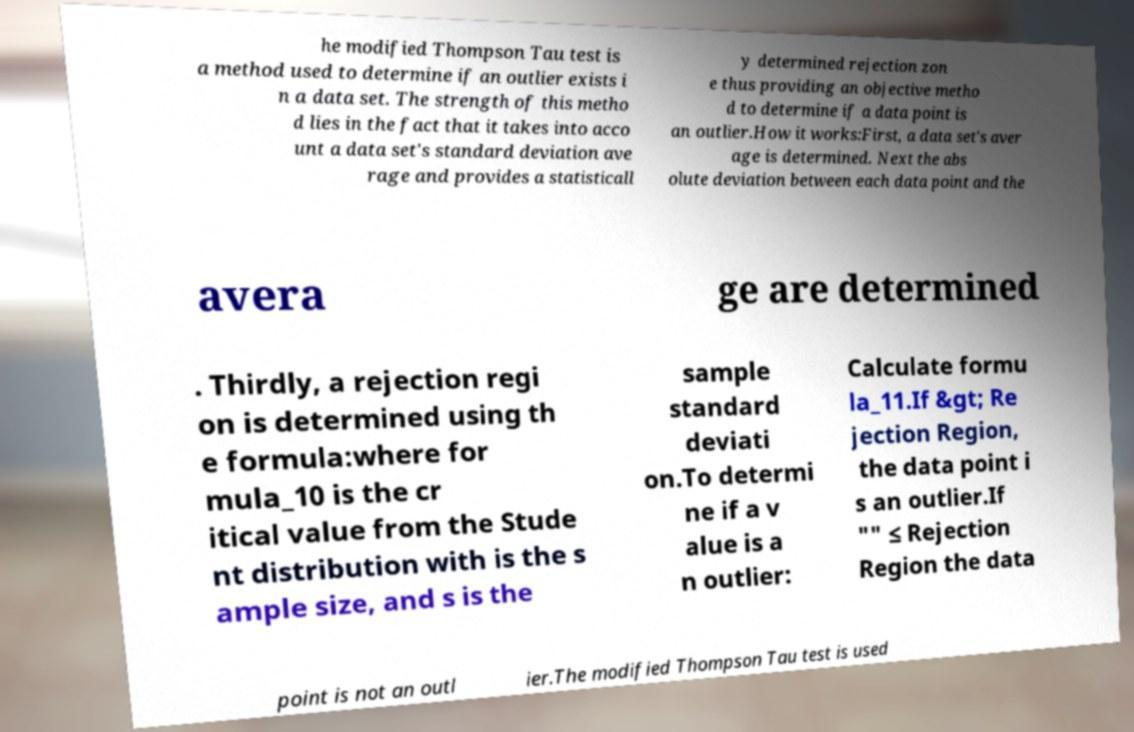Could you assist in decoding the text presented in this image and type it out clearly? he modified Thompson Tau test is a method used to determine if an outlier exists i n a data set. The strength of this metho d lies in the fact that it takes into acco unt a data set's standard deviation ave rage and provides a statisticall y determined rejection zon e thus providing an objective metho d to determine if a data point is an outlier.How it works:First, a data set's aver age is determined. Next the abs olute deviation between each data point and the avera ge are determined . Thirdly, a rejection regi on is determined using th e formula:where for mula_10 is the cr itical value from the Stude nt distribution with is the s ample size, and s is the sample standard deviati on.To determi ne if a v alue is a n outlier: Calculate formu la_11.If &gt; Re jection Region, the data point i s an outlier.If "" ≤ Rejection Region the data point is not an outl ier.The modified Thompson Tau test is used 